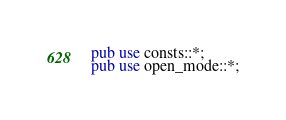<code> <loc_0><loc_0><loc_500><loc_500><_Rust_>
pub use consts::*;
pub use open_mode::*;</code> 